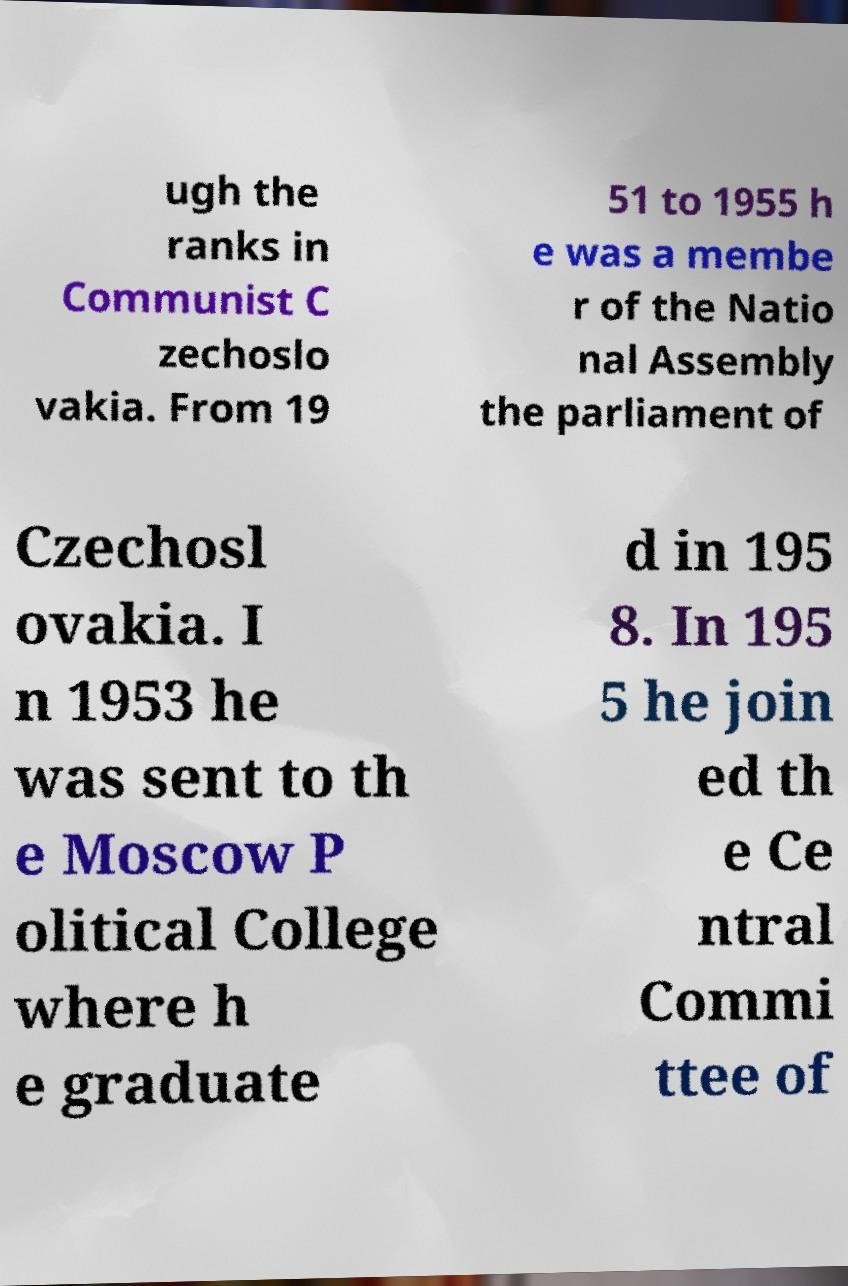There's text embedded in this image that I need extracted. Can you transcribe it verbatim? ugh the ranks in Communist C zechoslo vakia. From 19 51 to 1955 h e was a membe r of the Natio nal Assembly the parliament of Czechosl ovakia. I n 1953 he was sent to th e Moscow P olitical College where h e graduate d in 195 8. In 195 5 he join ed th e Ce ntral Commi ttee of 